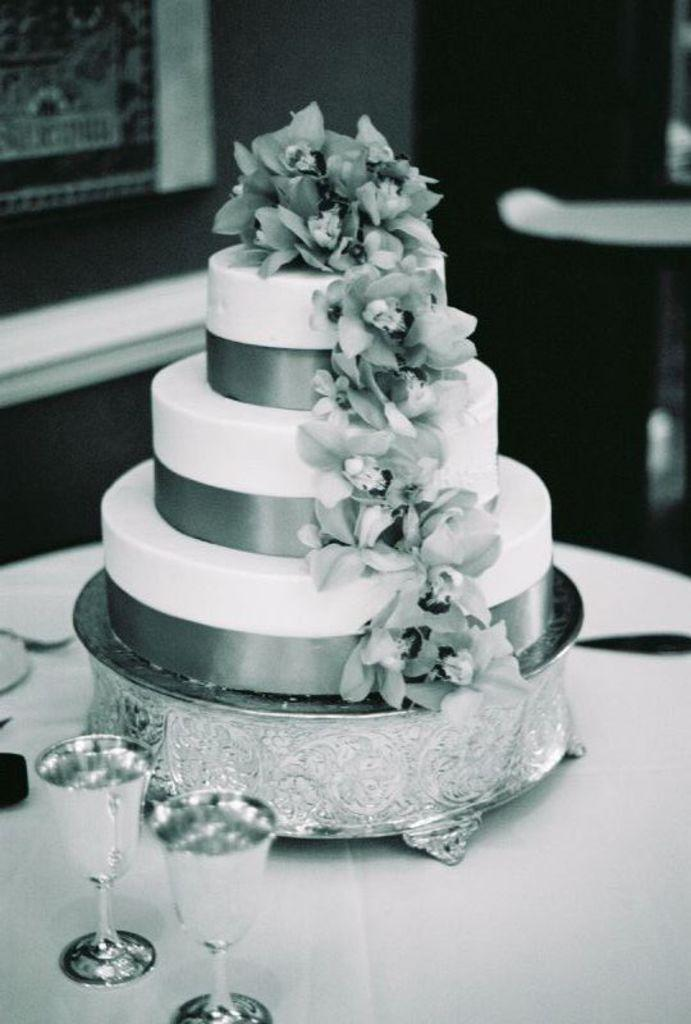What is the main food item visible in the image? There is a cake in the image. What else can be seen on the table besides the cake? There are glasses visible in the image. Where are the cake and glasses located? The cake and glasses are on a table. How would you describe the overall appearance of the image? The image is black and white, and the background is blurred. How many fish are swimming in the cake in the image? There are no fish present in the image, as it features a cake and glasses on a table. 